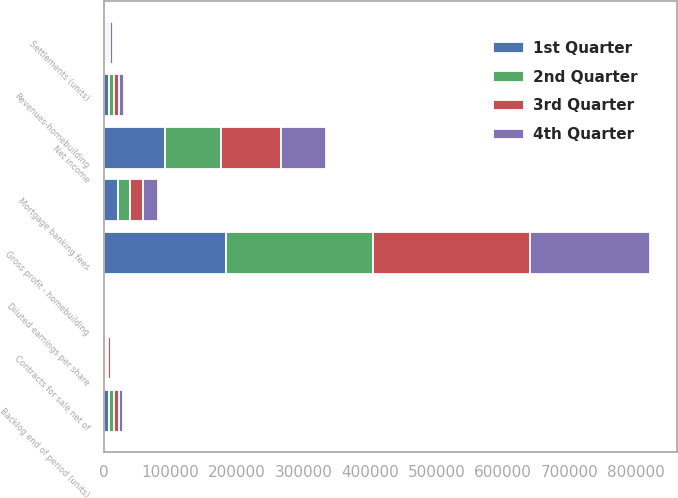Convert chart. <chart><loc_0><loc_0><loc_500><loc_500><stacked_bar_chart><ecel><fcel>Revenues-homebuilding<fcel>Gross profit - homebuilding<fcel>Mortgage banking fees<fcel>Net income<fcel>Diluted earnings per share<fcel>Contracts for sale net of<fcel>Settlements (units)<fcel>Backlog end of period (units)<nl><fcel>4th Quarter<fcel>7338<fcel>181153<fcel>21931<fcel>67274<fcel>11.72<fcel>1948<fcel>3874<fcel>5145<nl><fcel>1st Quarter<fcel>7338<fcel>183072<fcel>21617<fcel>91113<fcel>15.26<fcel>2660<fcel>3476<fcel>7071<nl><fcel>3rd Quarter<fcel>7338<fcel>235203<fcel>19528<fcel>90747<fcel>14.14<fcel>3745<fcel>3463<fcel>7887<nl><fcel>2nd Quarter<fcel>7338<fcel>221700<fcel>18079<fcel>84821<fcel>12.96<fcel>3917<fcel>2700<fcel>7605<nl></chart> 